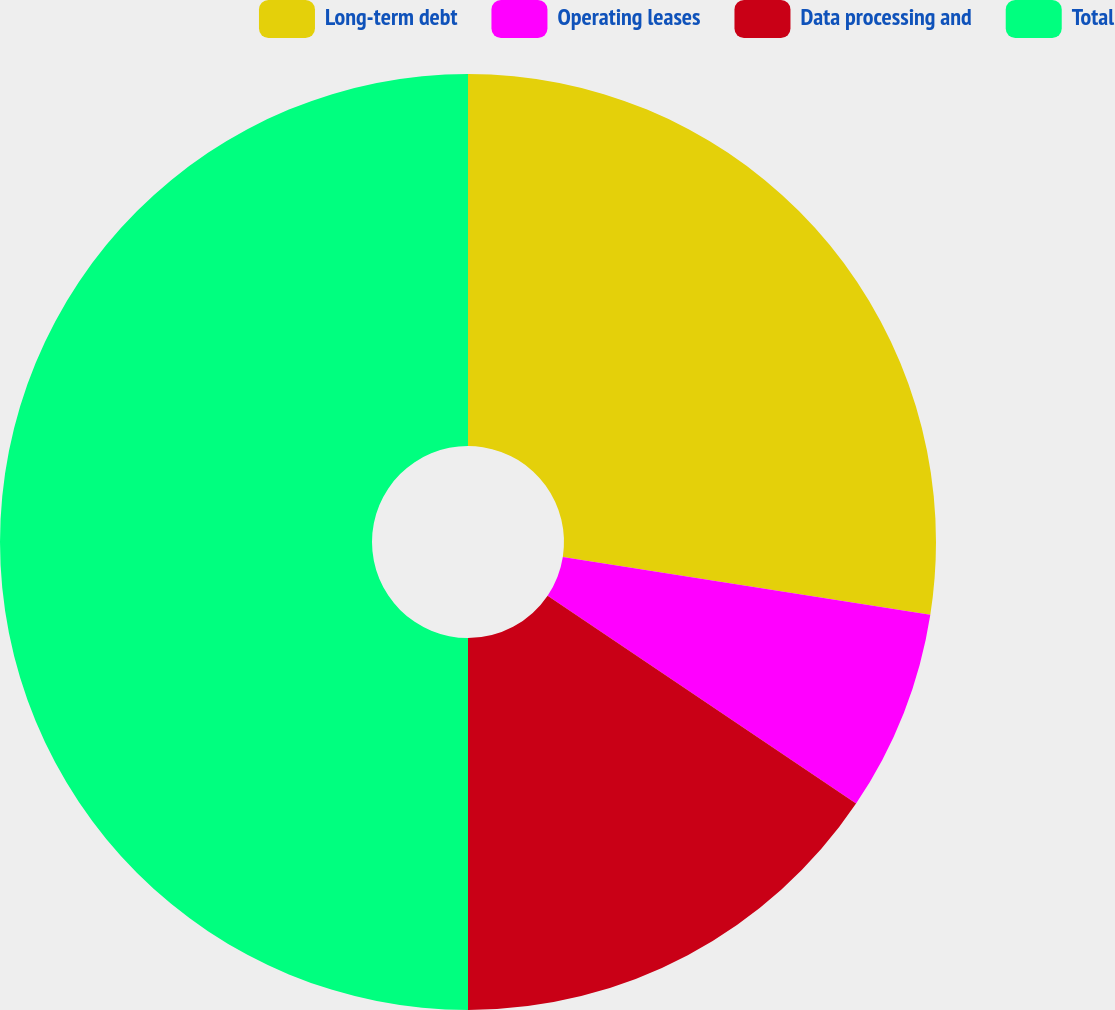Convert chart. <chart><loc_0><loc_0><loc_500><loc_500><pie_chart><fcel>Long-term debt<fcel>Operating leases<fcel>Data processing and<fcel>Total<nl><fcel>27.48%<fcel>6.96%<fcel>15.56%<fcel>50.0%<nl></chart> 